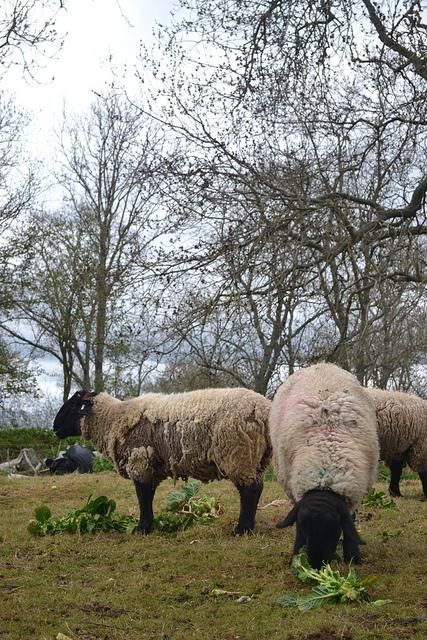How many sheeps are seen?
Short answer required. 3. What are the sheep eating?
Concise answer only. Grass. What color is the pasture?
Short answer required. Green. What color are the sheeps heads?
Give a very brief answer. Black. 